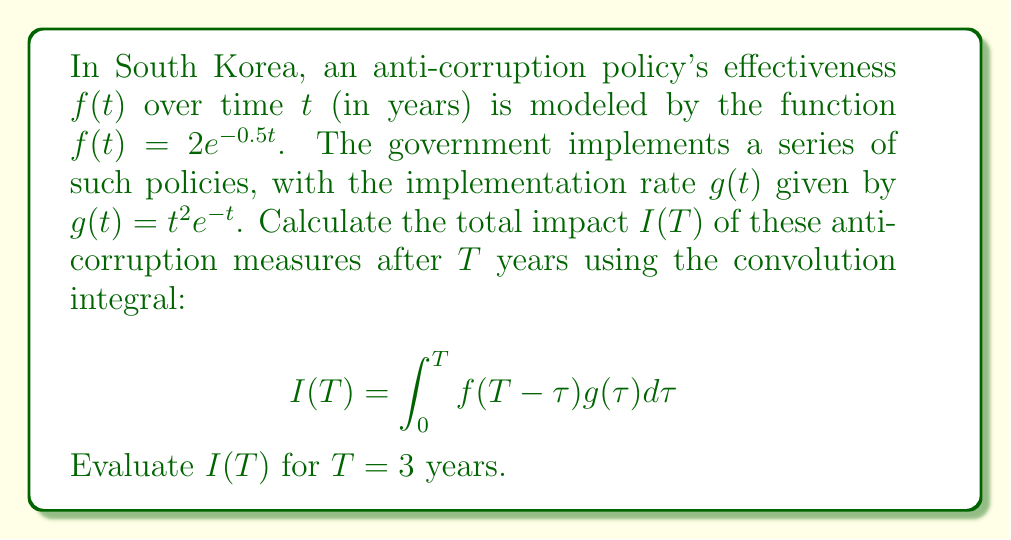Give your solution to this math problem. Let's approach this step-by-step:

1) We need to calculate the convolution integral:
   $$I(T) = \int_0^T f(T-\tau)g(\tau)d\tau$$

2) Substitute the given functions:
   $$I(T) = \int_0^T 2e^{-0.5(T-\tau)} \cdot \tau^2e^{-\tau}d\tau$$

3) Simplify the integrand:
   $$I(T) = 2e^{-0.5T}\int_0^T \tau^2e^{-0.5\tau}d\tau$$

4) Now, we need to evaluate this for T = 3:
   $$I(3) = 2e^{-1.5}\int_0^3 \tau^2e^{-0.5\tau}d\tau$$

5) To solve this integral, we can use integration by parts twice:
   Let $u = \tau^2$ and $dv = e^{-0.5\tau}d\tau$
   Then $du = 2\tau d\tau$ and $v = -2e^{-0.5\tau}$

6) Applying integration by parts:
   $$I(3) = 2e^{-1.5}[-2\tau^2e^{-0.5\tau}]_0^3 + 2e^{-1.5}\int_0^3 4\tau e^{-0.5\tau}d\tau$$

7) Solve the remaining integral using integration by parts again:
   $$I(3) = 2e^{-1.5}(-18e^{-1.5}) + 8e^{-1.5}[-2\tau e^{-0.5\tau}]_0^3 + 8e^{-1.5}\int_0^3 2e^{-0.5\tau}d\tau$$

8) Evaluate the final integral:
   $$I(3) = -36e^{-3} + 8e^{-1.5}(-6e^{-1.5}) + 32e^{-1.5}[-e^{-0.5\tau}]_0^3$$

9) Simplify:
   $$I(3) = -36e^{-3} - 48e^{-3} + 32e^{-1.5}(1-e^{-1.5})$$

10) Calculate the final result:
    $$I(3) \approx 0.7978$$
Answer: 0.7978 